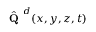<formula> <loc_0><loc_0><loc_500><loc_500>\hat { Q } ^ { d } ( x , y , z , { t } )</formula> 